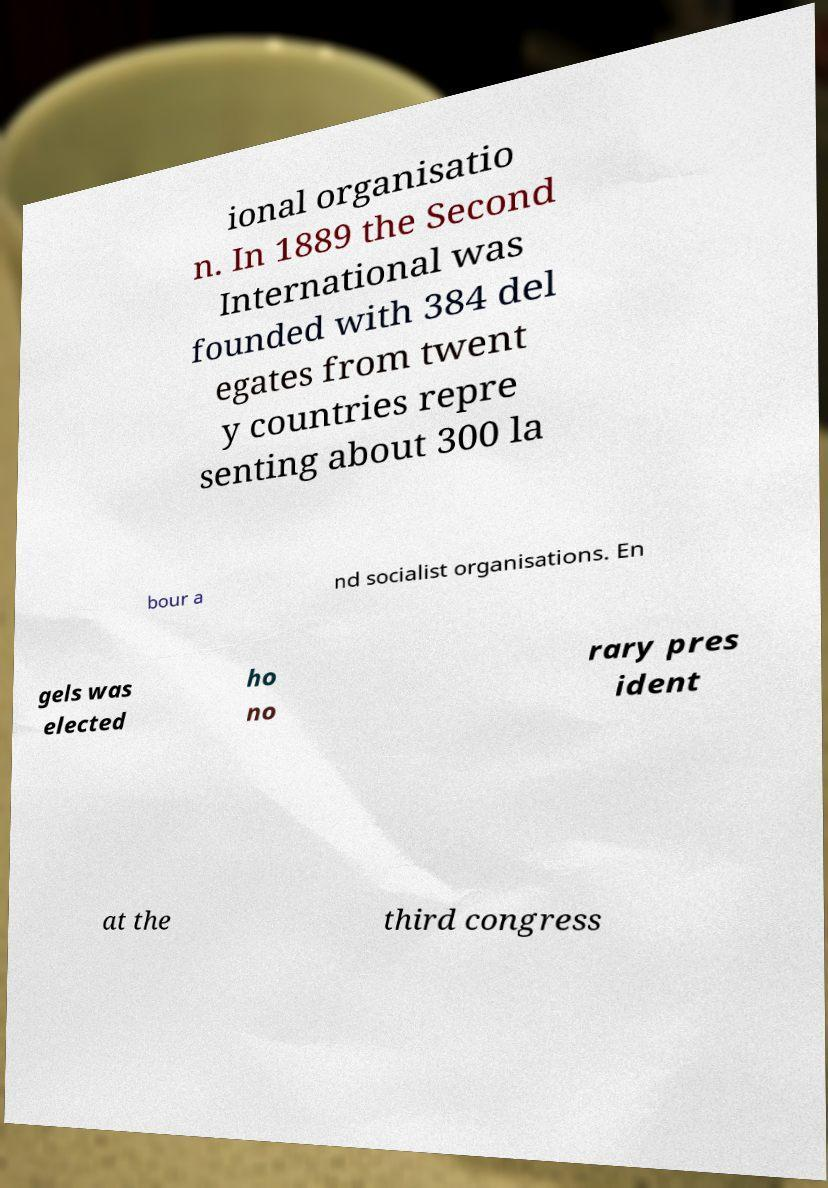Please identify and transcribe the text found in this image. ional organisatio n. In 1889 the Second International was founded with 384 del egates from twent y countries repre senting about 300 la bour a nd socialist organisations. En gels was elected ho no rary pres ident at the third congress 